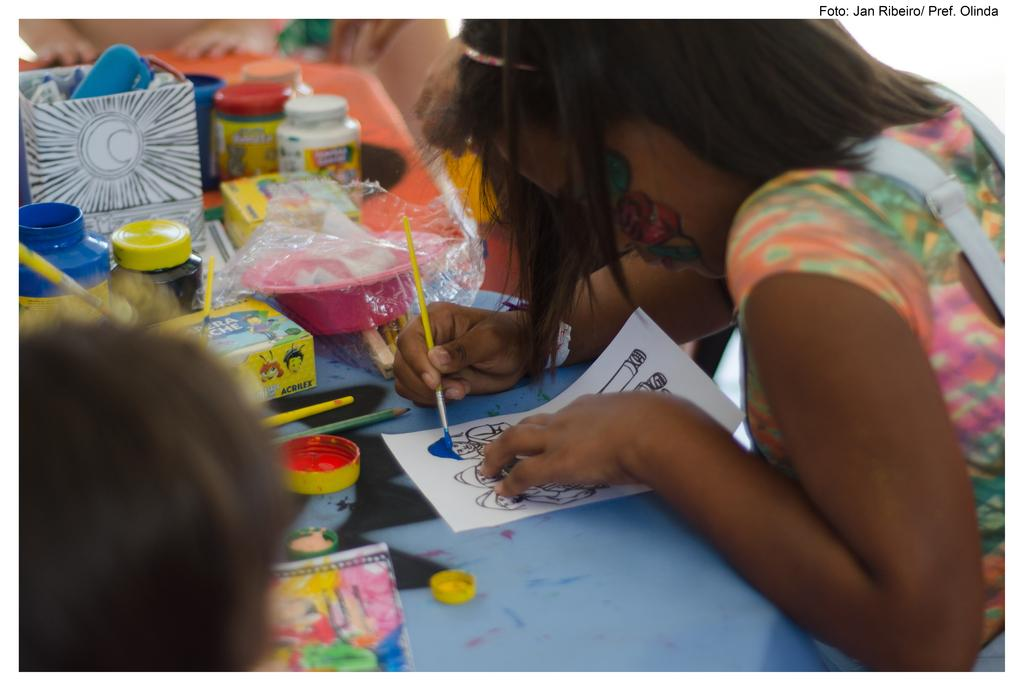Who is the main subject in the image? There is a girl in the image. What is the girl doing in the image? The girl is painting. What is the girl using to paint? There are paints on the table in the image. Where is the boy located in the image? The boy is on the left side of the image. What is the distance between the girl and the event happening in the image? There is no event happening in the image; it only shows a girl painting and a boy on the left side. 